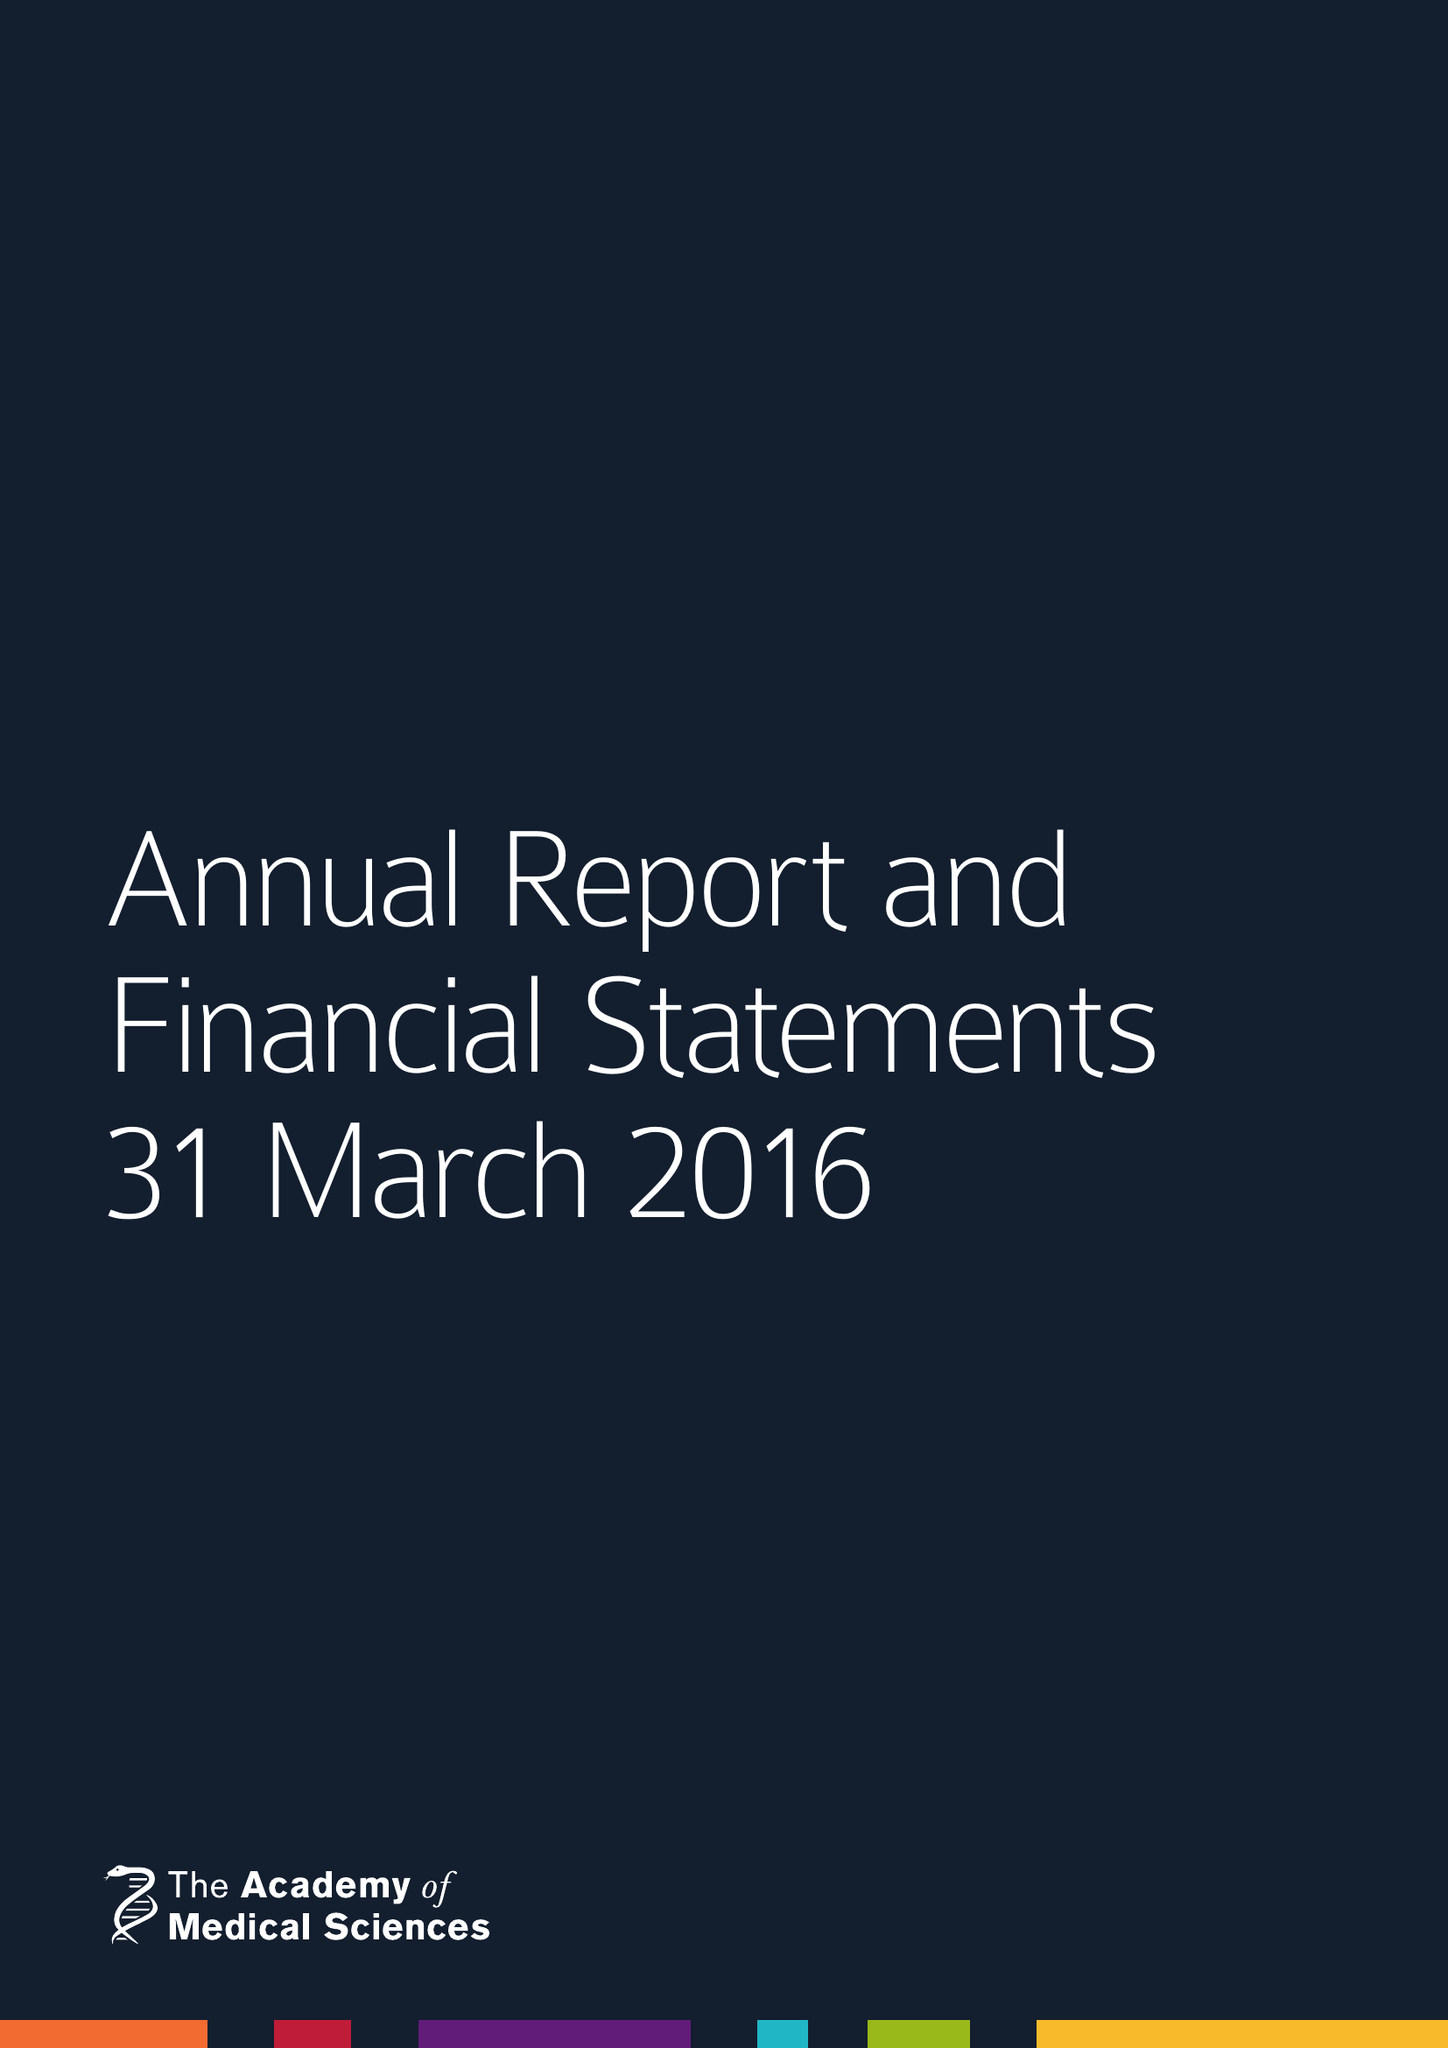What is the value for the charity_number?
Answer the question using a single word or phrase. 1070618 